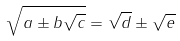<formula> <loc_0><loc_0><loc_500><loc_500>\sqrt { a \pm b \sqrt { c } } = \sqrt { d } \pm \sqrt { e }</formula> 